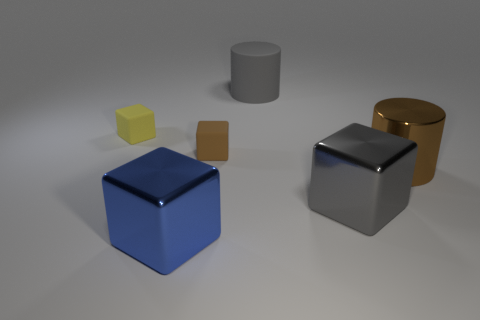There is a large metal thing that is behind the gray object in front of the large brown cylinder; what color is it? The object described appears to be a gold-colored cylinder behind the gray cube and in front of the larger brown cylinder in the image. Its reflective metallic surface and cylindrical shape give it a distinct and shiny gold appearance. 